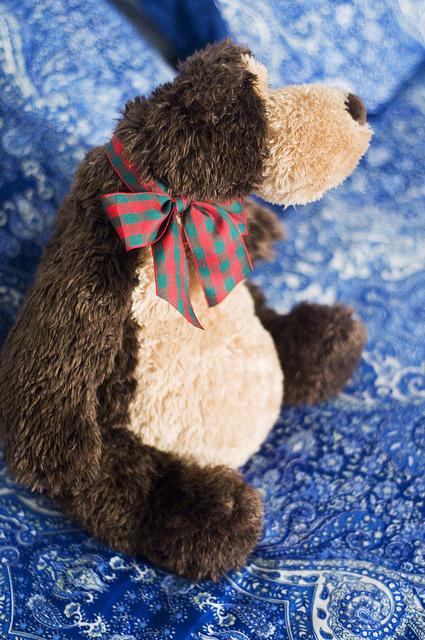What type of material is the stuffed animal made out of?
Be succinct. Cotton. What is around the toy's neck?
Answer briefly. Bow. What color is the bedspread?
Concise answer only. Blue. What shape is the ribbon around the bears neck?
Write a very short answer. Bow. What color is the bear?
Quick response, please. Brown. 